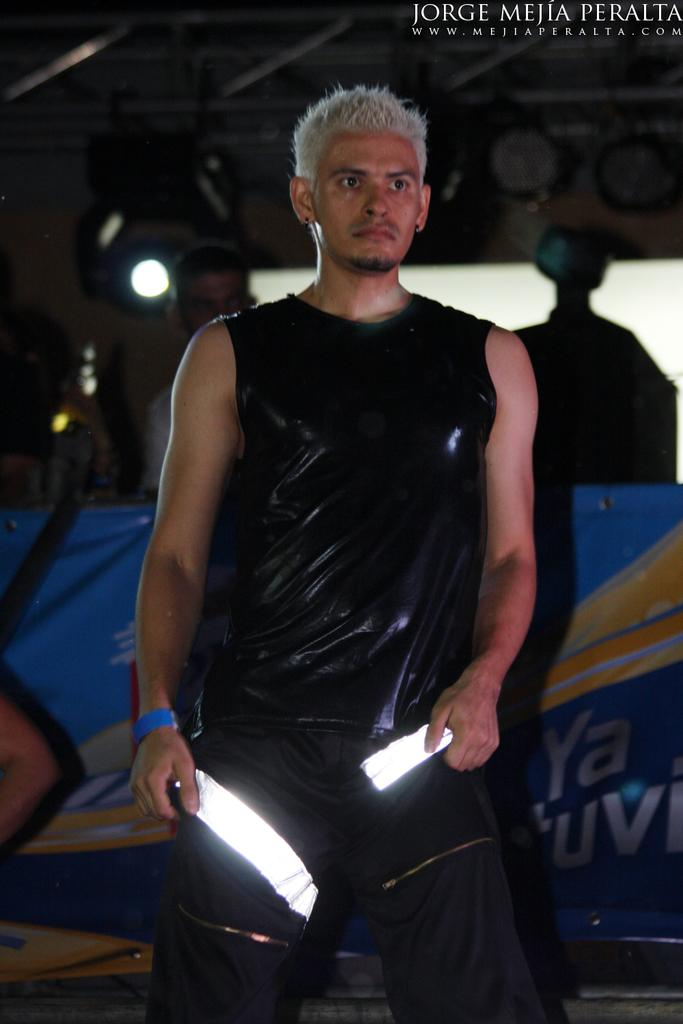<image>
Share a concise interpretation of the image provided. a man in black standing below a Jorge Mejia Peralta banner banner 